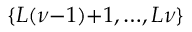Convert formula to latex. <formula><loc_0><loc_0><loc_500><loc_500>\{ L ( \nu { - } 1 ) { + } 1 , { \dots } , L \nu \}</formula> 